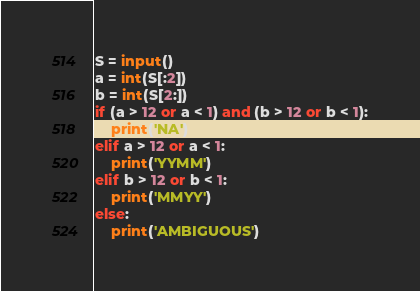<code> <loc_0><loc_0><loc_500><loc_500><_Python_>S = input()
a = int(S[:2])
b = int(S[2:])
if (a > 12 or a < 1) and (b > 12 or b < 1):
    print('NA')
elif a > 12 or a < 1:
    print('YYMM')
elif b > 12 or b < 1:
    print('MMYY')
else:
    print('AMBIGUOUS')</code> 